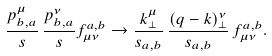Convert formula to latex. <formula><loc_0><loc_0><loc_500><loc_500>\frac { p _ { b , a } ^ { \mu } } s \, \frac { p _ { b , a } ^ { \nu } } s f _ { \mu \nu } ^ { a , b } \rightarrow \frac { k _ { \perp } ^ { \mu } } { s _ { a , b } } \, \frac { ( q - k ) _ { \perp } ^ { \nu } } { s _ { a , b } } \, f _ { \mu \nu } ^ { a , b } .</formula> 